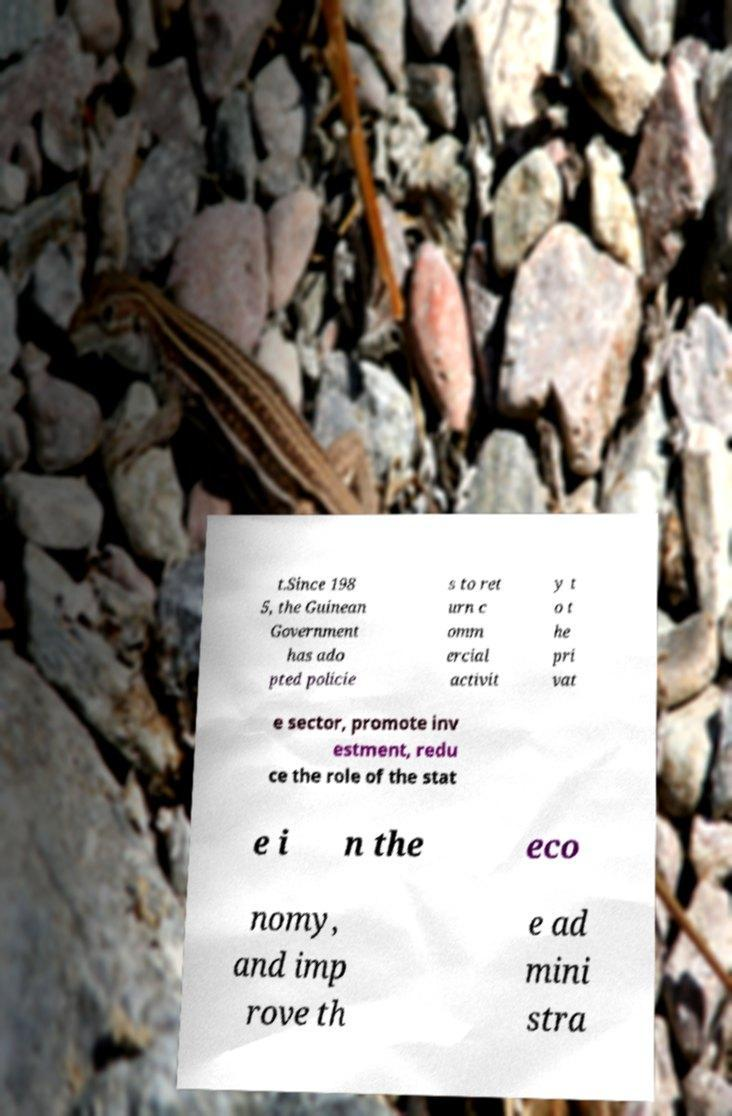What messages or text are displayed in this image? I need them in a readable, typed format. t.Since 198 5, the Guinean Government has ado pted policie s to ret urn c omm ercial activit y t o t he pri vat e sector, promote inv estment, redu ce the role of the stat e i n the eco nomy, and imp rove th e ad mini stra 